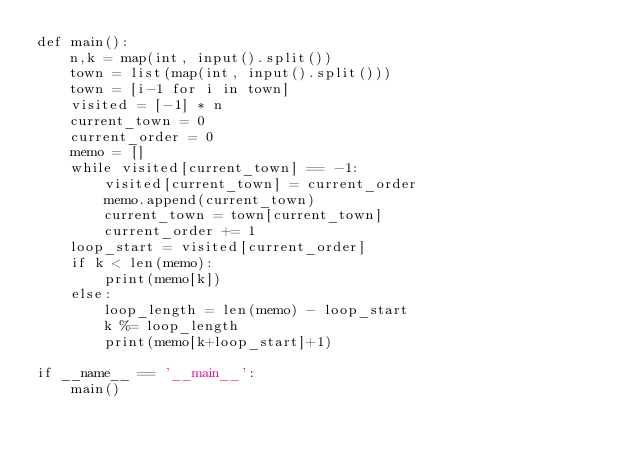<code> <loc_0><loc_0><loc_500><loc_500><_Python_>def main():
    n,k = map(int, input().split())
    town = list(map(int, input().split()))
    town = [i-1 for i in town]
    visited = [-1] * n
    current_town = 0
    current_order = 0
    memo = []
    while visited[current_town] == -1:
        visited[current_town] = current_order
        memo.append(current_town)
        current_town = town[current_town]
        current_order += 1
    loop_start = visited[current_order]
    if k < len(memo):
        print(memo[k])
    else:
        loop_length = len(memo) - loop_start
        k %= loop_length
        print(memo[k+loop_start]+1)

if __name__ == '__main__':
    main()</code> 